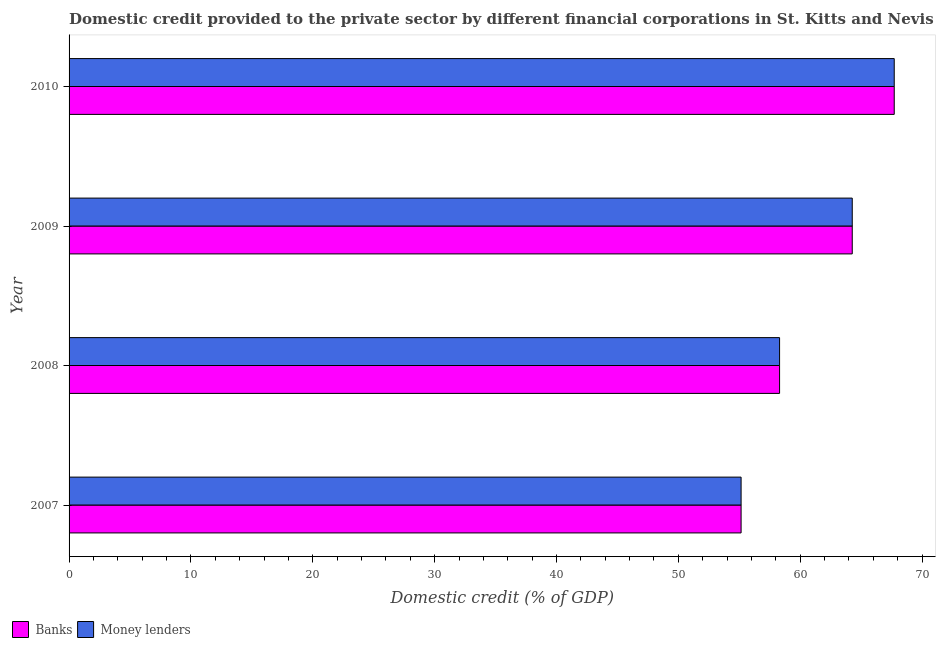Are the number of bars on each tick of the Y-axis equal?
Offer a very short reply. Yes. How many bars are there on the 4th tick from the top?
Make the answer very short. 2. What is the label of the 3rd group of bars from the top?
Offer a very short reply. 2008. In how many cases, is the number of bars for a given year not equal to the number of legend labels?
Keep it short and to the point. 0. What is the domestic credit provided by money lenders in 2009?
Your response must be concise. 64.27. Across all years, what is the maximum domestic credit provided by banks?
Your answer should be compact. 67.72. Across all years, what is the minimum domestic credit provided by money lenders?
Keep it short and to the point. 55.15. In which year was the domestic credit provided by banks minimum?
Offer a terse response. 2007. What is the total domestic credit provided by money lenders in the graph?
Offer a terse response. 245.45. What is the difference between the domestic credit provided by money lenders in 2007 and that in 2009?
Your answer should be very brief. -9.12. What is the difference between the domestic credit provided by banks in 2008 and the domestic credit provided by money lenders in 2010?
Offer a very short reply. -9.41. What is the average domestic credit provided by banks per year?
Offer a very short reply. 61.36. In the year 2010, what is the difference between the domestic credit provided by money lenders and domestic credit provided by banks?
Provide a short and direct response. 0. In how many years, is the domestic credit provided by banks greater than 58 %?
Offer a very short reply. 3. What is the ratio of the domestic credit provided by money lenders in 2008 to that in 2010?
Your answer should be very brief. 0.86. What is the difference between the highest and the second highest domestic credit provided by money lenders?
Offer a terse response. 3.45. What is the difference between the highest and the lowest domestic credit provided by money lenders?
Your answer should be very brief. 12.57. In how many years, is the domestic credit provided by banks greater than the average domestic credit provided by banks taken over all years?
Provide a short and direct response. 2. What does the 2nd bar from the top in 2008 represents?
Make the answer very short. Banks. What does the 2nd bar from the bottom in 2008 represents?
Offer a very short reply. Money lenders. Does the graph contain any zero values?
Keep it short and to the point. No. What is the title of the graph?
Offer a terse response. Domestic credit provided to the private sector by different financial corporations in St. Kitts and Nevis. Does "Females" appear as one of the legend labels in the graph?
Provide a succinct answer. No. What is the label or title of the X-axis?
Keep it short and to the point. Domestic credit (% of GDP). What is the Domestic credit (% of GDP) of Banks in 2007?
Your answer should be compact. 55.15. What is the Domestic credit (% of GDP) in Money lenders in 2007?
Your answer should be compact. 55.15. What is the Domestic credit (% of GDP) of Banks in 2008?
Ensure brevity in your answer.  58.31. What is the Domestic credit (% of GDP) in Money lenders in 2008?
Keep it short and to the point. 58.31. What is the Domestic credit (% of GDP) of Banks in 2009?
Provide a short and direct response. 64.27. What is the Domestic credit (% of GDP) of Money lenders in 2009?
Provide a succinct answer. 64.27. What is the Domestic credit (% of GDP) of Banks in 2010?
Keep it short and to the point. 67.72. What is the Domestic credit (% of GDP) in Money lenders in 2010?
Your answer should be very brief. 67.72. Across all years, what is the maximum Domestic credit (% of GDP) in Banks?
Offer a very short reply. 67.72. Across all years, what is the maximum Domestic credit (% of GDP) in Money lenders?
Your answer should be compact. 67.72. Across all years, what is the minimum Domestic credit (% of GDP) of Banks?
Ensure brevity in your answer.  55.15. Across all years, what is the minimum Domestic credit (% of GDP) in Money lenders?
Provide a short and direct response. 55.15. What is the total Domestic credit (% of GDP) in Banks in the graph?
Make the answer very short. 245.45. What is the total Domestic credit (% of GDP) of Money lenders in the graph?
Keep it short and to the point. 245.45. What is the difference between the Domestic credit (% of GDP) in Banks in 2007 and that in 2008?
Offer a terse response. -3.16. What is the difference between the Domestic credit (% of GDP) in Money lenders in 2007 and that in 2008?
Offer a terse response. -3.16. What is the difference between the Domestic credit (% of GDP) of Banks in 2007 and that in 2009?
Your answer should be compact. -9.12. What is the difference between the Domestic credit (% of GDP) in Money lenders in 2007 and that in 2009?
Provide a short and direct response. -9.12. What is the difference between the Domestic credit (% of GDP) of Banks in 2007 and that in 2010?
Your response must be concise. -12.57. What is the difference between the Domestic credit (% of GDP) in Money lenders in 2007 and that in 2010?
Your answer should be compact. -12.57. What is the difference between the Domestic credit (% of GDP) of Banks in 2008 and that in 2009?
Ensure brevity in your answer.  -5.96. What is the difference between the Domestic credit (% of GDP) in Money lenders in 2008 and that in 2009?
Make the answer very short. -5.96. What is the difference between the Domestic credit (% of GDP) of Banks in 2008 and that in 2010?
Keep it short and to the point. -9.41. What is the difference between the Domestic credit (% of GDP) in Money lenders in 2008 and that in 2010?
Provide a short and direct response. -9.41. What is the difference between the Domestic credit (% of GDP) in Banks in 2009 and that in 2010?
Ensure brevity in your answer.  -3.45. What is the difference between the Domestic credit (% of GDP) of Money lenders in 2009 and that in 2010?
Give a very brief answer. -3.45. What is the difference between the Domestic credit (% of GDP) of Banks in 2007 and the Domestic credit (% of GDP) of Money lenders in 2008?
Keep it short and to the point. -3.16. What is the difference between the Domestic credit (% of GDP) of Banks in 2007 and the Domestic credit (% of GDP) of Money lenders in 2009?
Offer a very short reply. -9.12. What is the difference between the Domestic credit (% of GDP) in Banks in 2007 and the Domestic credit (% of GDP) in Money lenders in 2010?
Offer a terse response. -12.57. What is the difference between the Domestic credit (% of GDP) in Banks in 2008 and the Domestic credit (% of GDP) in Money lenders in 2009?
Give a very brief answer. -5.96. What is the difference between the Domestic credit (% of GDP) of Banks in 2008 and the Domestic credit (% of GDP) of Money lenders in 2010?
Ensure brevity in your answer.  -9.41. What is the difference between the Domestic credit (% of GDP) of Banks in 2009 and the Domestic credit (% of GDP) of Money lenders in 2010?
Your answer should be compact. -3.45. What is the average Domestic credit (% of GDP) of Banks per year?
Your answer should be very brief. 61.36. What is the average Domestic credit (% of GDP) in Money lenders per year?
Your answer should be compact. 61.36. In the year 2008, what is the difference between the Domestic credit (% of GDP) of Banks and Domestic credit (% of GDP) of Money lenders?
Provide a succinct answer. 0. In the year 2009, what is the difference between the Domestic credit (% of GDP) of Banks and Domestic credit (% of GDP) of Money lenders?
Offer a very short reply. 0. What is the ratio of the Domestic credit (% of GDP) of Banks in 2007 to that in 2008?
Your answer should be compact. 0.95. What is the ratio of the Domestic credit (% of GDP) of Money lenders in 2007 to that in 2008?
Your response must be concise. 0.95. What is the ratio of the Domestic credit (% of GDP) of Banks in 2007 to that in 2009?
Provide a succinct answer. 0.86. What is the ratio of the Domestic credit (% of GDP) in Money lenders in 2007 to that in 2009?
Give a very brief answer. 0.86. What is the ratio of the Domestic credit (% of GDP) of Banks in 2007 to that in 2010?
Provide a short and direct response. 0.81. What is the ratio of the Domestic credit (% of GDP) in Money lenders in 2007 to that in 2010?
Give a very brief answer. 0.81. What is the ratio of the Domestic credit (% of GDP) of Banks in 2008 to that in 2009?
Make the answer very short. 0.91. What is the ratio of the Domestic credit (% of GDP) of Money lenders in 2008 to that in 2009?
Keep it short and to the point. 0.91. What is the ratio of the Domestic credit (% of GDP) of Banks in 2008 to that in 2010?
Offer a very short reply. 0.86. What is the ratio of the Domestic credit (% of GDP) in Money lenders in 2008 to that in 2010?
Make the answer very short. 0.86. What is the ratio of the Domestic credit (% of GDP) of Banks in 2009 to that in 2010?
Ensure brevity in your answer.  0.95. What is the ratio of the Domestic credit (% of GDP) in Money lenders in 2009 to that in 2010?
Offer a terse response. 0.95. What is the difference between the highest and the second highest Domestic credit (% of GDP) in Banks?
Ensure brevity in your answer.  3.45. What is the difference between the highest and the second highest Domestic credit (% of GDP) in Money lenders?
Give a very brief answer. 3.45. What is the difference between the highest and the lowest Domestic credit (% of GDP) in Banks?
Offer a very short reply. 12.57. What is the difference between the highest and the lowest Domestic credit (% of GDP) of Money lenders?
Ensure brevity in your answer.  12.57. 